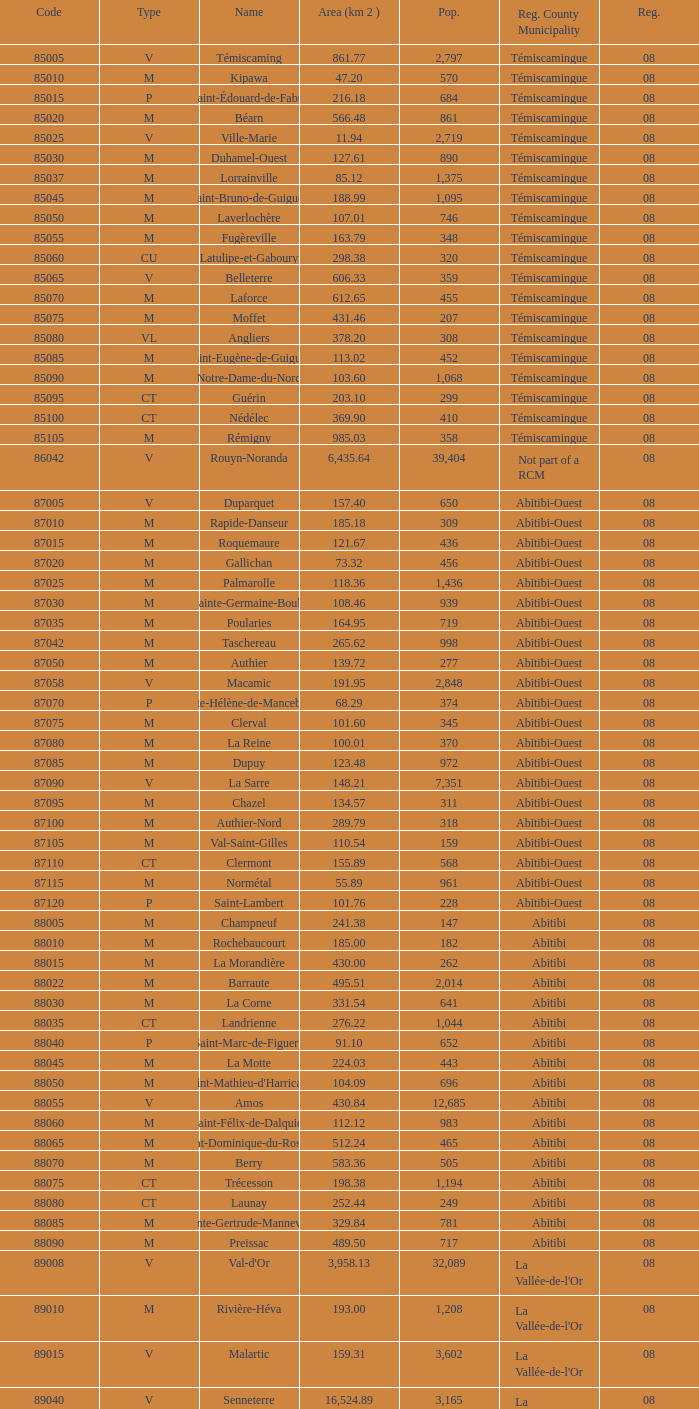What is the km2 area for the population of 311? 134.57. 